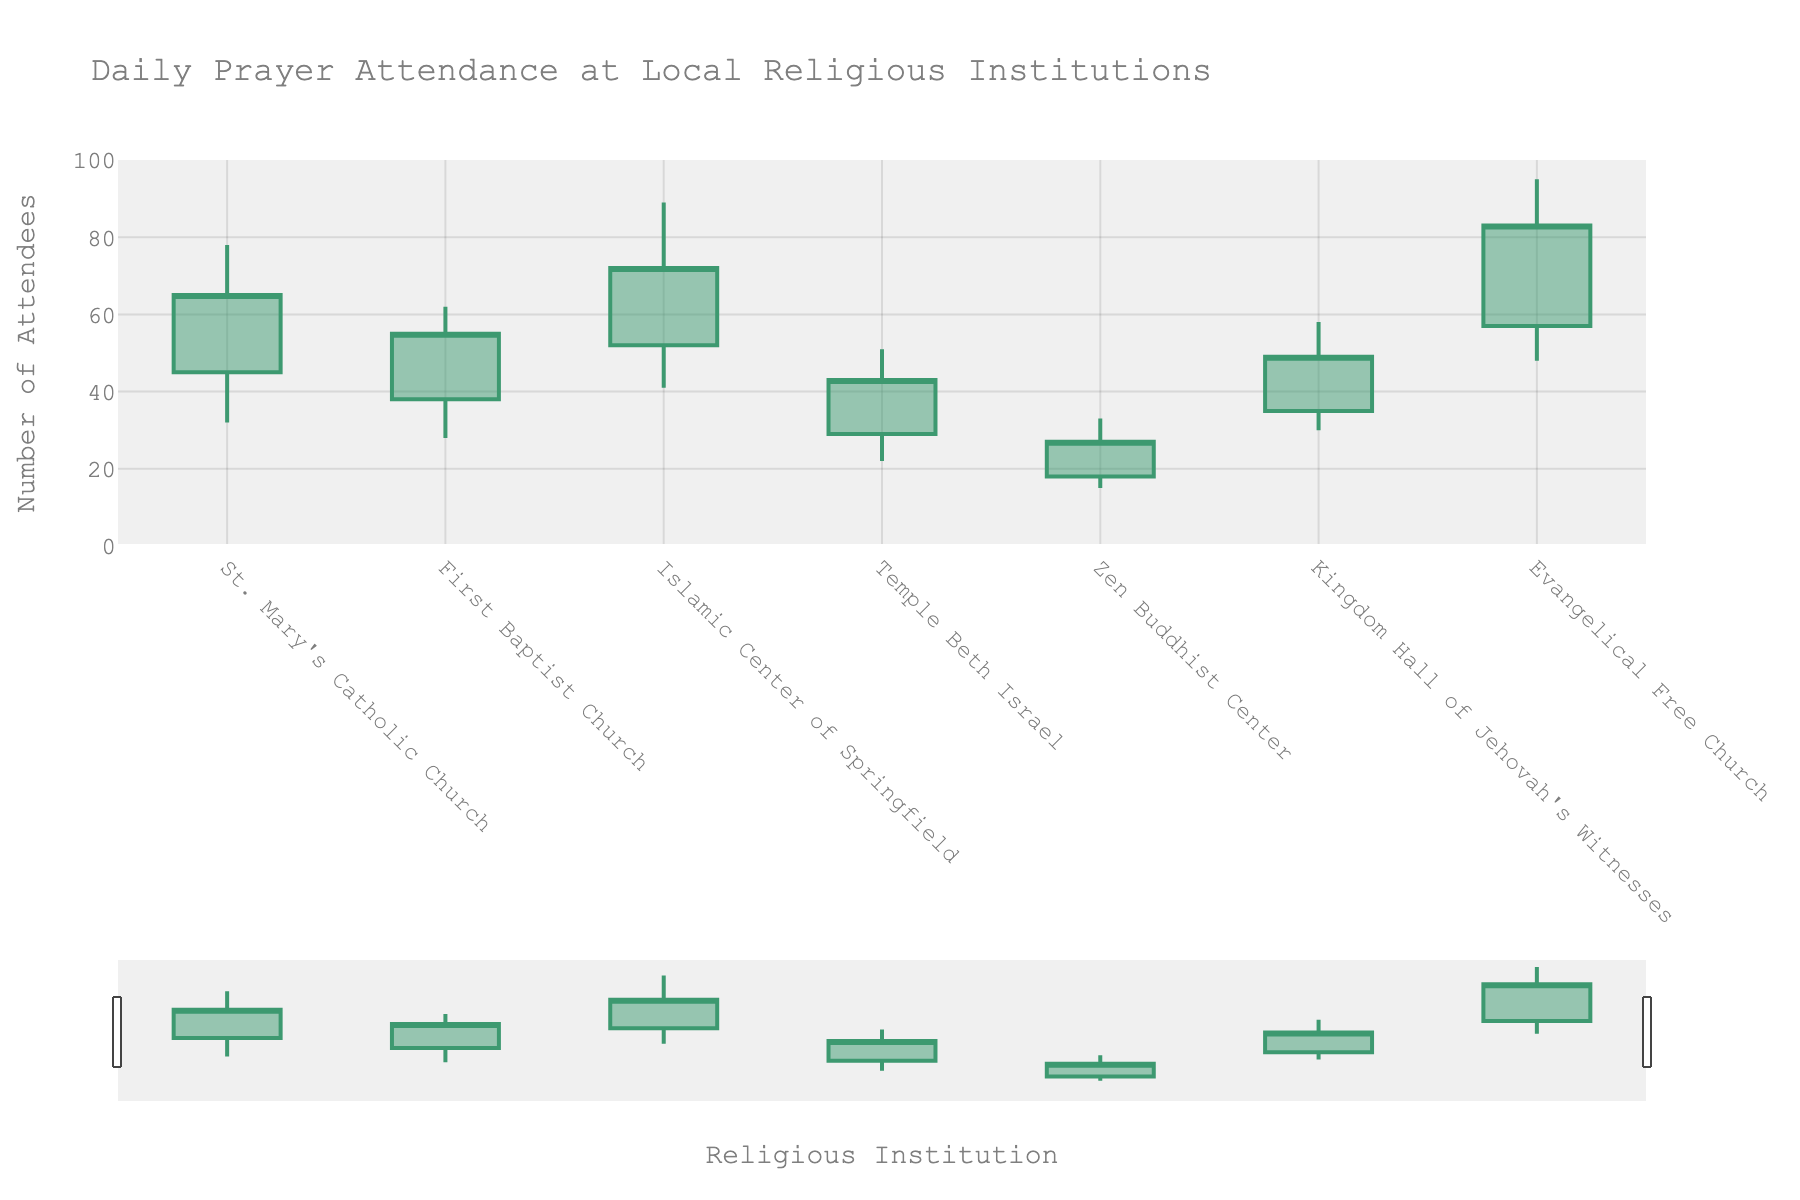what does the title of the figure say? The title is usually located at the top of the figure and it provides a summary of what the figure is about. Here, the title is 'Daily Prayer Attendance at Local Religious Institutions'.
Answer: Daily Prayer Attendance at Local Religious Institutions How many religious institutions are represented in the chart? Count the number of unique institutions listed on the x-axis to determine the total number of religious institutions. There are seven unique institutions from the data provided.
Answer: Seven Which institution had the highest attendance on their highest day? To find this, identify the highest 'high' value among all institutions and see which institution it corresponds to. The highest 'high' value is 95 attendees from Evangelical Free Church.
Answer: Evangelical Free Church What is the range of attendees for Kingdom Hall of Jehovah's Witnesses? The range is calculated by subtracting the 'low' value from the 'high' value for Kingdom Hall of Jehovah's Witnesses. Here, the high is 58 and the low is 30. So, 58 - 30 = 28.
Answer: 28 Which institution had the least variability in attendance? The institution with the least variability will have the smallest difference between the high and low values. Here, Zen Buddhist Center has the smallest range with a high of 33 and a low of 15, resulting in a difference of 18.
Answer: Zen Buddhist Center What was the lowest recorded attendance across all institutions? Look for the smallest 'low' value in the chart. The lowest recorded attendance is 15 attendees at Zen Buddhist Center.
Answer: 15 Among the institutions, which had a closing attendance higher than the opening attendance? Compare the 'open' and 'close' values for each institution. The institutions with a higher 'close' than 'open' values are: St. Mary's Catholic Church, Islamic Center of Springfield, and Evangelical Free Church.
Answer: St. Mary’s Catholic Church, Islamic Center of Springfield, Evangelical Free Church Did any institution have both the opening and closing attendance higher than 50 attendees? Check each institution's 'open' and 'close' values to see if they are both greater than 50. There are no institutions that meet this criteria.
Answer: None What is the average closing attendance across all institutions? Sum all the 'close' values and divide by the total number of institutions, which is 7. (65 + 55 + 72 + 43 + 27 + 49 + 83) / 7 = 394 / 7 ≈ 56.29.
Answer: approximately 56.29 